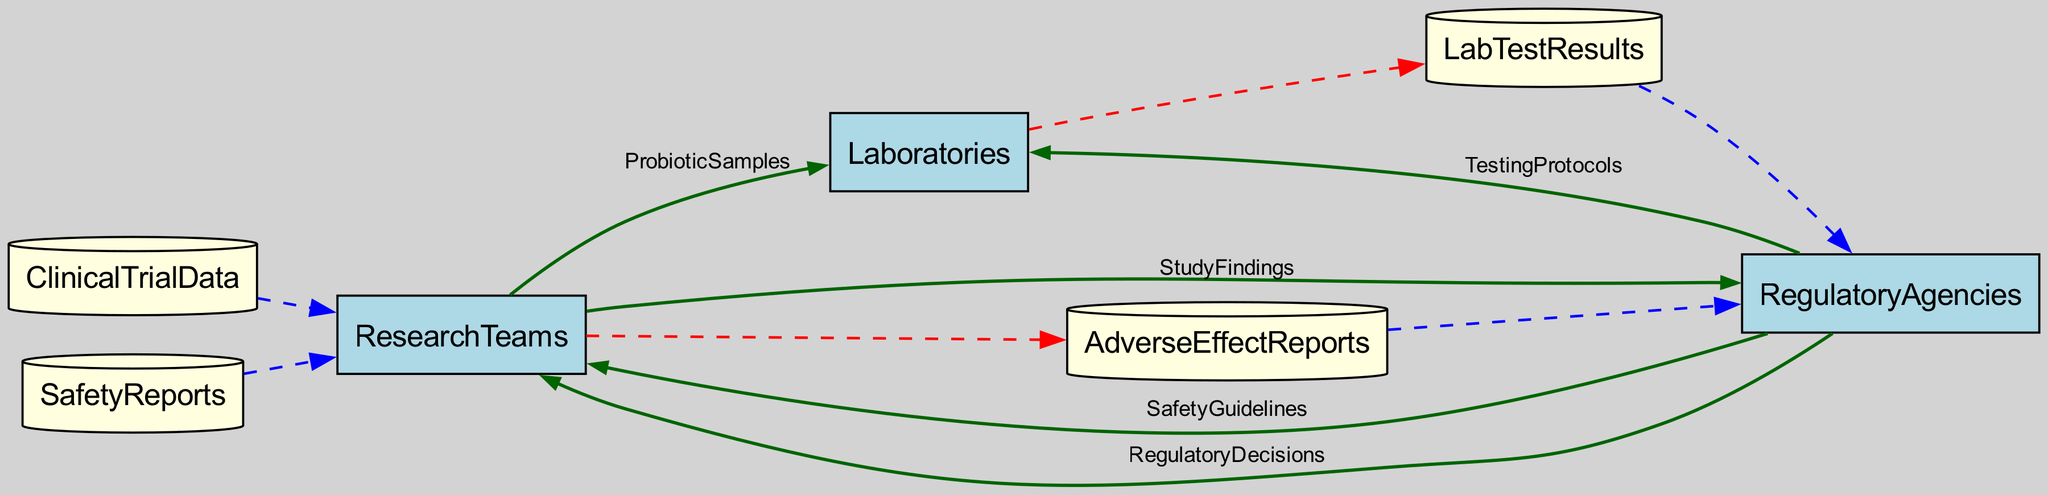What types of entities are present in the diagram? The diagram includes three types of entities: Research Teams, Laboratories, and Regulatory Agencies. Each type represents a distinct role in the drug-safety assessment process for probiotics.
Answer: Research Teams, Laboratories, Regulatory Agencies How many data stores are identified in the diagram? The diagram shows four data stores: Clinical Trial Data, Safety Reports, Lab Test Results, and Adverse Effect Reports. These stores hold important information used during the assessment process.
Answer: Four What is the output of the Research Teams? Research Teams output Study Findings and Adverse Effect Reports based on their research efforts on probiotics. These outputs are critical for further evaluations by regulatory bodies.
Answer: Study Findings, Adverse Effect Reports Which entity provides Testing Protocols to Laboratories? The Regulatory Agencies provide Testing Protocols to Laboratories to ensure standardized procedures are followed during the testing of probiotic samples.
Answer: Regulatory Agencies What data flows from Research Teams to Regulatory Agencies? The data that flows from Research Teams to Regulatory Agencies includes Study Findings, which summarize the results of their investigations, along with any Adverse Effect Reports that may have been documented.
Answer: Study Findings, Adverse Effect Reports Why do Laboratories receive Probiotic Samples from Research Teams? Laboratories receive Probiotic Samples from Research Teams to perform detailed testing aimed at assessing the safety of the probiotics before any regulatory decisions can be made.
Answer: To assess safety What are the outputs of Laboratories in this diagram? Laboratories produce Lab Test Results as their output after testing probiotic samples based on the provided Testing Protocols from Regulatory Agencies.
Answer: Lab Test Results How do Regulatory Agencies use the inputs they receive? Regulatory Agencies use Study Findings, Lab Test Results, and Adverse Effect Reports to formulate Safety Guidelines and make Regulatory Decisions on probiotic supplements.
Answer: To formulate Safety Guidelines and Regulatory Decisions How does data flow to Research Teams after guidelines are issued? After Safety Guidelines are issued by Regulatory Agencies, the guidelines flow back to Research Teams, influencing their future studies and assessments of probiotic supplements.
Answer: Safety Guidelines flow back to Research Teams 